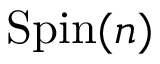<formula> <loc_0><loc_0><loc_500><loc_500>{ S p i n } ( n )</formula> 